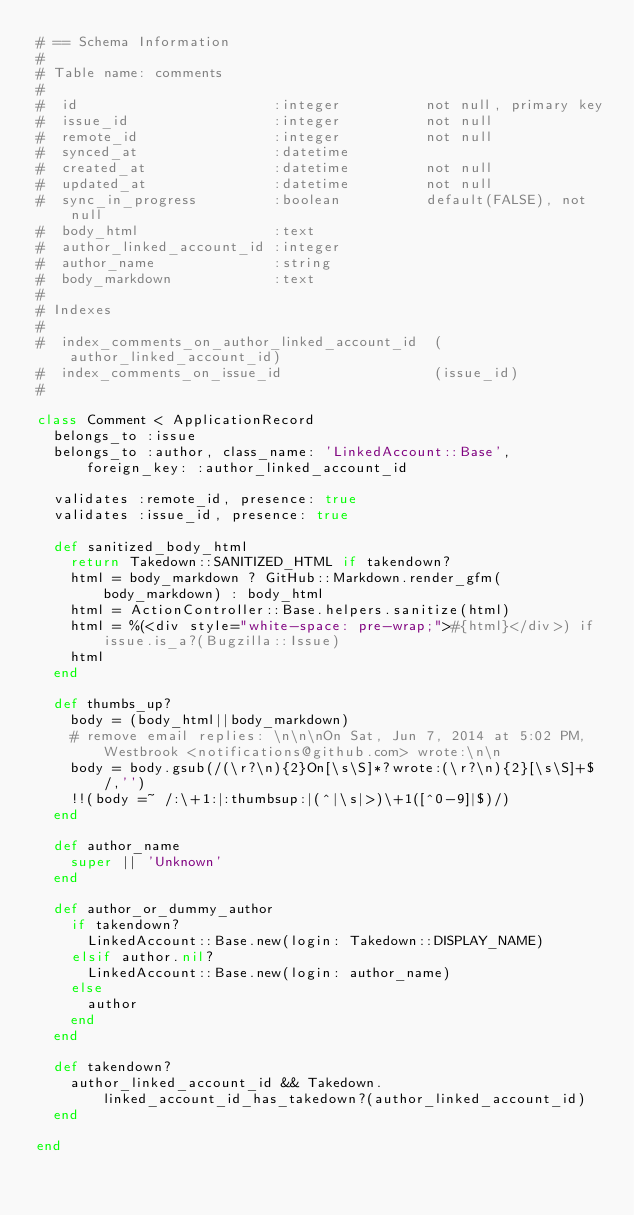Convert code to text. <code><loc_0><loc_0><loc_500><loc_500><_Ruby_># == Schema Information
#
# Table name: comments
#
#  id                       :integer          not null, primary key
#  issue_id                 :integer          not null
#  remote_id                :integer          not null
#  synced_at                :datetime
#  created_at               :datetime         not null
#  updated_at               :datetime         not null
#  sync_in_progress         :boolean          default(FALSE), not null
#  body_html                :text
#  author_linked_account_id :integer
#  author_name              :string
#  body_markdown            :text
#
# Indexes
#
#  index_comments_on_author_linked_account_id  (author_linked_account_id)
#  index_comments_on_issue_id                  (issue_id)
#

class Comment < ApplicationRecord
  belongs_to :issue
  belongs_to :author, class_name: 'LinkedAccount::Base', foreign_key: :author_linked_account_id

  validates :remote_id, presence: true
  validates :issue_id, presence: true

  def sanitized_body_html
    return Takedown::SANITIZED_HTML if takendown?
    html = body_markdown ? GitHub::Markdown.render_gfm(body_markdown) : body_html
    html = ActionController::Base.helpers.sanitize(html)
    html = %(<div style="white-space: pre-wrap;">#{html}</div>) if issue.is_a?(Bugzilla::Issue)
    html
  end

  def thumbs_up?
    body = (body_html||body_markdown)
    # remove email replies: \n\n\nOn Sat, Jun 7, 2014 at 5:02 PM, Westbrook <notifications@github.com> wrote:\n\n
    body = body.gsub(/(\r?\n){2}On[\s\S]*?wrote:(\r?\n){2}[\s\S]+$/,'')
    !!(body =~ /:\+1:|:thumbsup:|(^|\s|>)\+1([^0-9]|$)/)
  end

  def author_name
    super || 'Unknown'
  end

  def author_or_dummy_author
    if takendown?
      LinkedAccount::Base.new(login: Takedown::DISPLAY_NAME)
    elsif author.nil?
      LinkedAccount::Base.new(login: author_name)
    else
      author
    end
  end

  def takendown?
    author_linked_account_id && Takedown.linked_account_id_has_takedown?(author_linked_account_id)
  end

end
</code> 